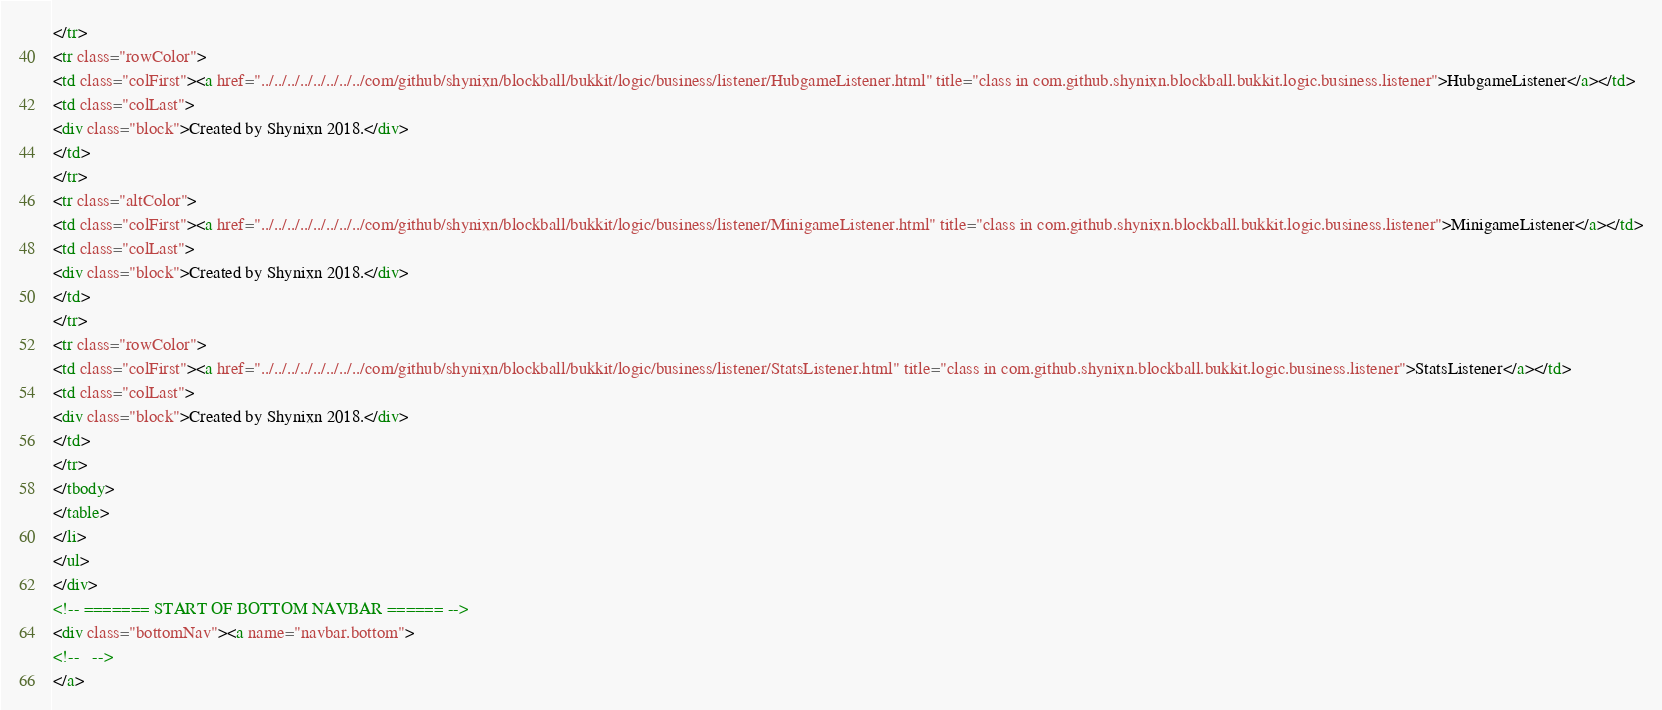Convert code to text. <code><loc_0><loc_0><loc_500><loc_500><_HTML_></tr>
<tr class="rowColor">
<td class="colFirst"><a href="../../../../../../../../com/github/shynixn/blockball/bukkit/logic/business/listener/HubgameListener.html" title="class in com.github.shynixn.blockball.bukkit.logic.business.listener">HubgameListener</a></td>
<td class="colLast">
<div class="block">Created by Shynixn 2018.</div>
</td>
</tr>
<tr class="altColor">
<td class="colFirst"><a href="../../../../../../../../com/github/shynixn/blockball/bukkit/logic/business/listener/MinigameListener.html" title="class in com.github.shynixn.blockball.bukkit.logic.business.listener">MinigameListener</a></td>
<td class="colLast">
<div class="block">Created by Shynixn 2018.</div>
</td>
</tr>
<tr class="rowColor">
<td class="colFirst"><a href="../../../../../../../../com/github/shynixn/blockball/bukkit/logic/business/listener/StatsListener.html" title="class in com.github.shynixn.blockball.bukkit.logic.business.listener">StatsListener</a></td>
<td class="colLast">
<div class="block">Created by Shynixn 2018.</div>
</td>
</tr>
</tbody>
</table>
</li>
</ul>
</div>
<!-- ======= START OF BOTTOM NAVBAR ====== -->
<div class="bottomNav"><a name="navbar.bottom">
<!--   -->
</a></code> 